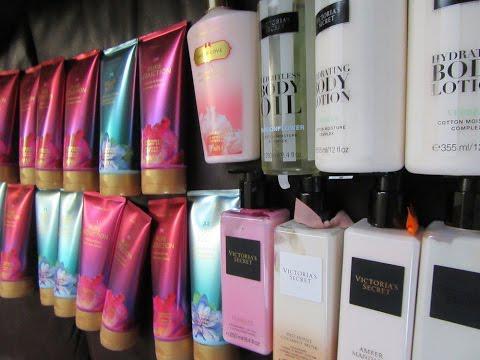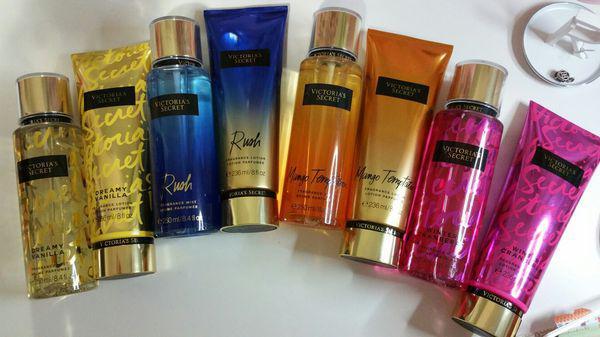The first image is the image on the left, the second image is the image on the right. Assess this claim about the two images: "There are less than five containers in at least one of the images.". Correct or not? Answer yes or no. No. The first image is the image on the left, the second image is the image on the right. For the images shown, is this caption "The right image includes only products with shiny gold caps and includes at least one tube-type product designed to stand on its cap." true? Answer yes or no. Yes. 